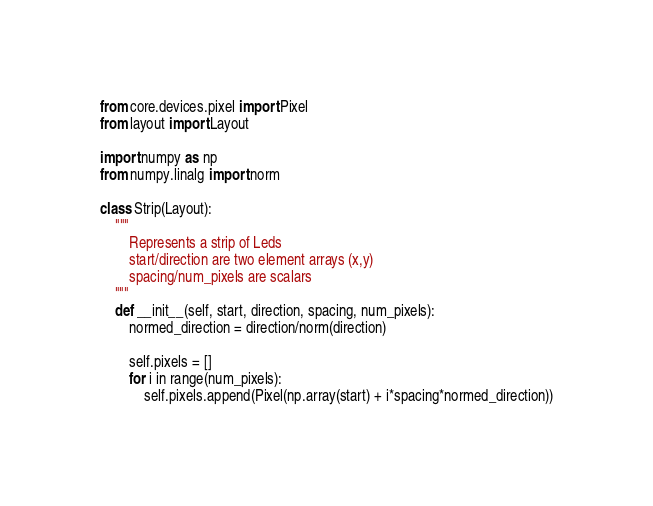<code> <loc_0><loc_0><loc_500><loc_500><_Python_>from core.devices.pixel import Pixel
from layout import Layout

import numpy as np
from numpy.linalg import norm

class Strip(Layout):
    """
        Represents a strip of Leds
        start/direction are two element arrays (x,y)
        spacing/num_pixels are scalars
    """
    def __init__(self, start, direction, spacing, num_pixels):
        normed_direction = direction/norm(direction)

        self.pixels = []
        for i in range(num_pixels):
            self.pixels.append(Pixel(np.array(start) + i*spacing*normed_direction))</code> 